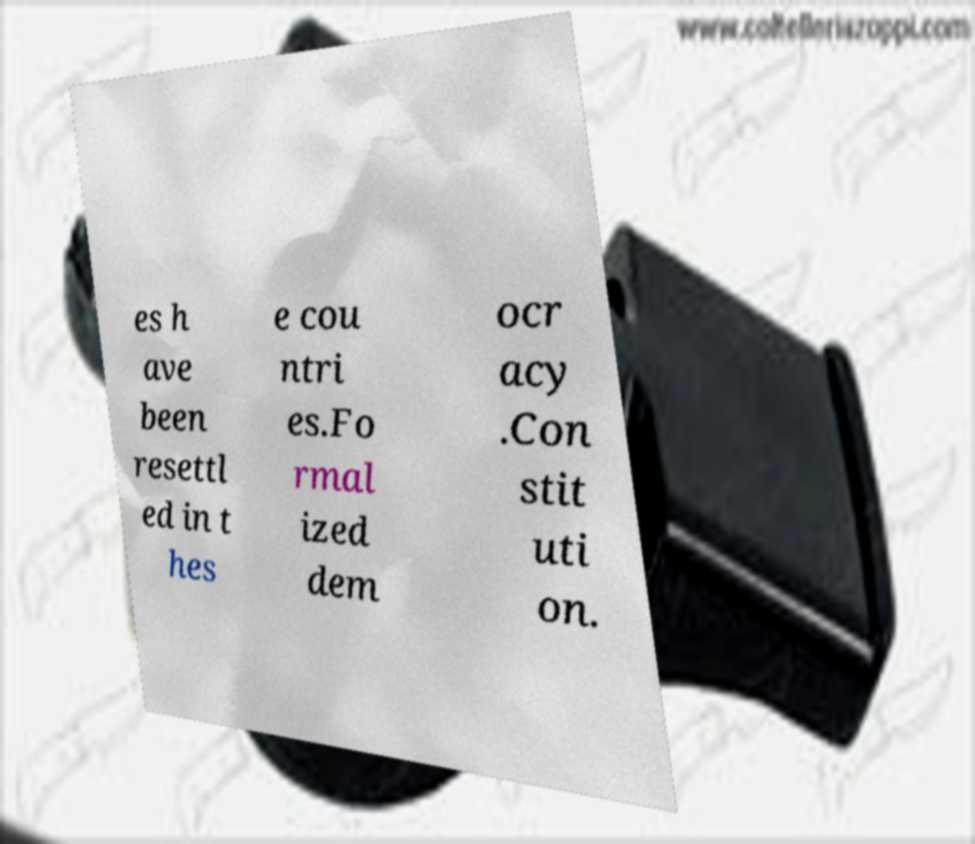For documentation purposes, I need the text within this image transcribed. Could you provide that? es h ave been resettl ed in t hes e cou ntri es.Fo rmal ized dem ocr acy .Con stit uti on. 